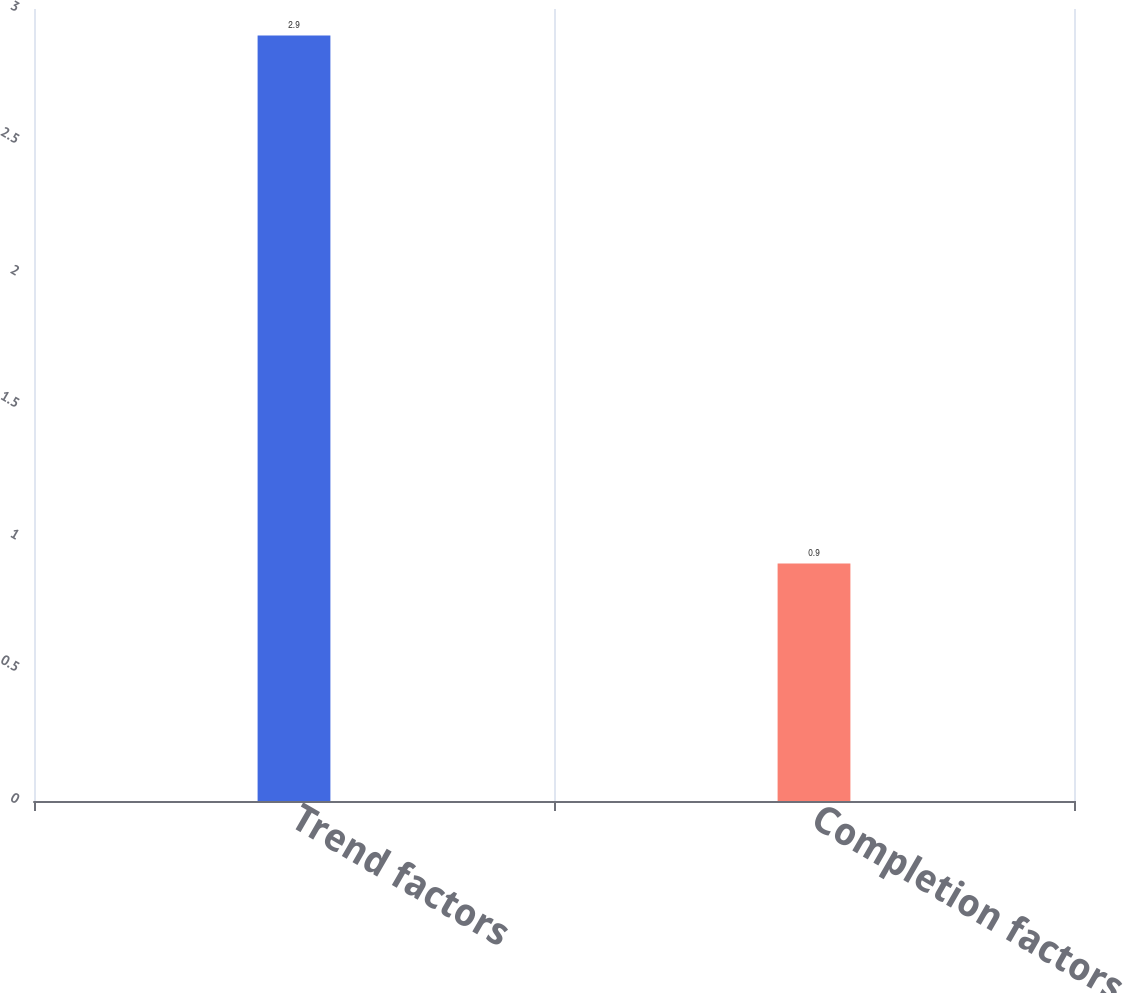<chart> <loc_0><loc_0><loc_500><loc_500><bar_chart><fcel>Trend factors<fcel>Completion factors<nl><fcel>2.9<fcel>0.9<nl></chart> 